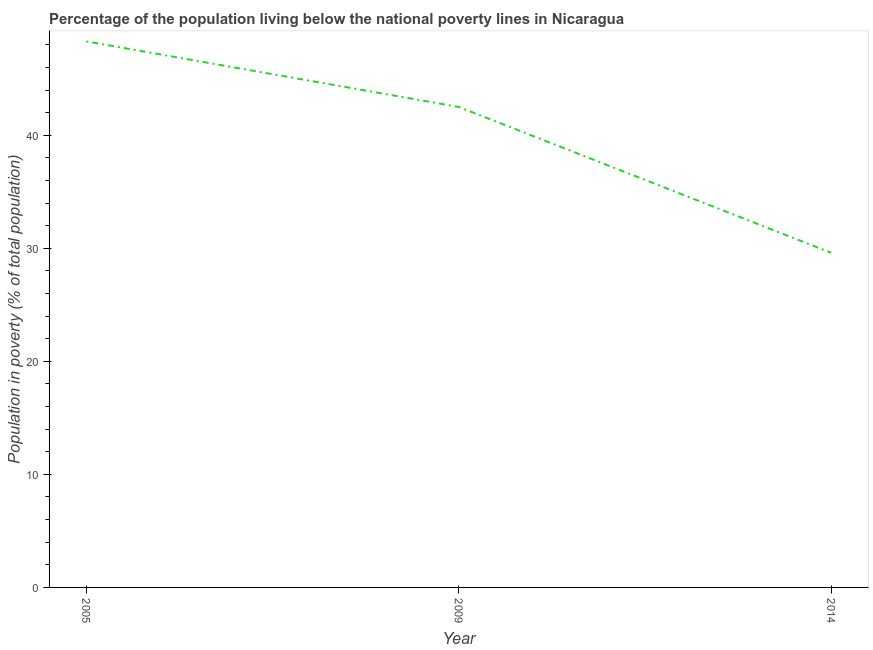What is the percentage of population living below poverty line in 2005?
Make the answer very short. 48.3. Across all years, what is the maximum percentage of population living below poverty line?
Your answer should be very brief. 48.3. Across all years, what is the minimum percentage of population living below poverty line?
Your answer should be very brief. 29.6. In which year was the percentage of population living below poverty line minimum?
Your answer should be very brief. 2014. What is the sum of the percentage of population living below poverty line?
Ensure brevity in your answer.  120.4. What is the difference between the percentage of population living below poverty line in 2009 and 2014?
Provide a short and direct response. 12.9. What is the average percentage of population living below poverty line per year?
Make the answer very short. 40.13. What is the median percentage of population living below poverty line?
Your answer should be compact. 42.5. Do a majority of the years between 2005 and 2014 (inclusive) have percentage of population living below poverty line greater than 20 %?
Your answer should be compact. Yes. What is the ratio of the percentage of population living below poverty line in 2005 to that in 2014?
Keep it short and to the point. 1.63. Is the percentage of population living below poverty line in 2009 less than that in 2014?
Your answer should be very brief. No. What is the difference between the highest and the second highest percentage of population living below poverty line?
Provide a short and direct response. 5.8. Is the sum of the percentage of population living below poverty line in 2005 and 2014 greater than the maximum percentage of population living below poverty line across all years?
Your response must be concise. Yes. What is the difference between the highest and the lowest percentage of population living below poverty line?
Offer a very short reply. 18.7. In how many years, is the percentage of population living below poverty line greater than the average percentage of population living below poverty line taken over all years?
Your answer should be compact. 2. What is the difference between two consecutive major ticks on the Y-axis?
Your answer should be compact. 10. Are the values on the major ticks of Y-axis written in scientific E-notation?
Ensure brevity in your answer.  No. Does the graph contain any zero values?
Your response must be concise. No. Does the graph contain grids?
Offer a terse response. No. What is the title of the graph?
Provide a succinct answer. Percentage of the population living below the national poverty lines in Nicaragua. What is the label or title of the Y-axis?
Keep it short and to the point. Population in poverty (% of total population). What is the Population in poverty (% of total population) in 2005?
Provide a succinct answer. 48.3. What is the Population in poverty (% of total population) in 2009?
Offer a terse response. 42.5. What is the Population in poverty (% of total population) of 2014?
Make the answer very short. 29.6. What is the difference between the Population in poverty (% of total population) in 2005 and 2009?
Make the answer very short. 5.8. What is the difference between the Population in poverty (% of total population) in 2005 and 2014?
Give a very brief answer. 18.7. What is the difference between the Population in poverty (% of total population) in 2009 and 2014?
Ensure brevity in your answer.  12.9. What is the ratio of the Population in poverty (% of total population) in 2005 to that in 2009?
Your answer should be very brief. 1.14. What is the ratio of the Population in poverty (% of total population) in 2005 to that in 2014?
Keep it short and to the point. 1.63. What is the ratio of the Population in poverty (% of total population) in 2009 to that in 2014?
Keep it short and to the point. 1.44. 